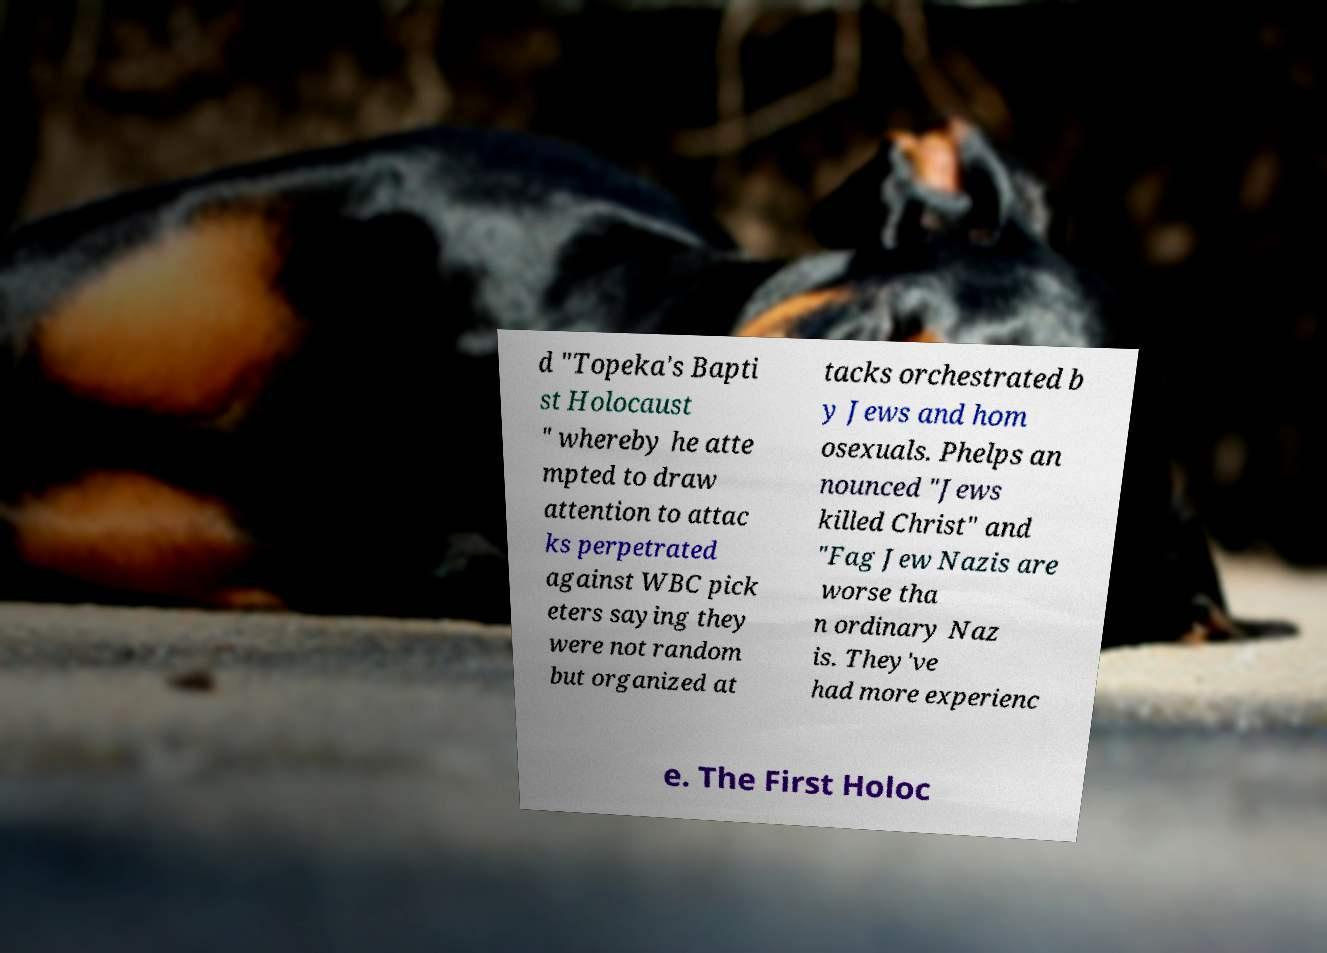I need the written content from this picture converted into text. Can you do that? d "Topeka's Bapti st Holocaust " whereby he atte mpted to draw attention to attac ks perpetrated against WBC pick eters saying they were not random but organized at tacks orchestrated b y Jews and hom osexuals. Phelps an nounced "Jews killed Christ" and "Fag Jew Nazis are worse tha n ordinary Naz is. They've had more experienc e. The First Holoc 